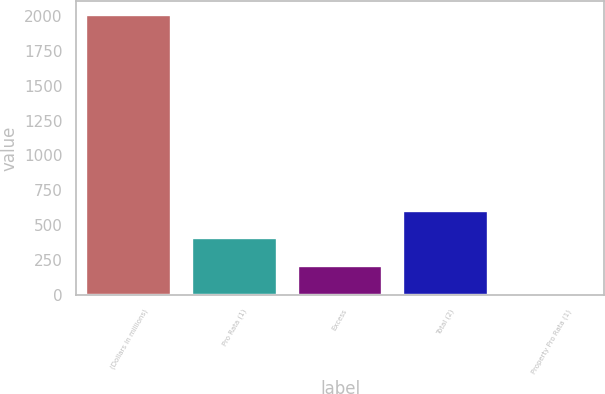<chart> <loc_0><loc_0><loc_500><loc_500><bar_chart><fcel>(Dollars in millions)<fcel>Pro Rata (1)<fcel>Excess<fcel>Total (2)<fcel>Property Pro Rata (1)<nl><fcel>2005<fcel>405<fcel>205<fcel>605<fcel>5<nl></chart> 